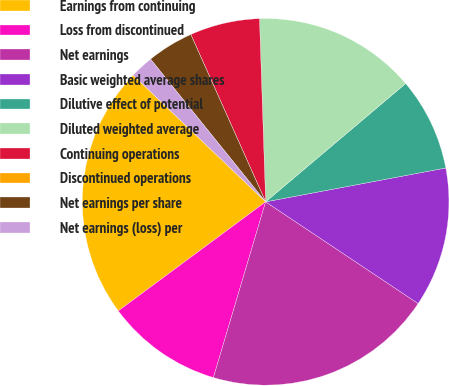Convert chart. <chart><loc_0><loc_0><loc_500><loc_500><pie_chart><fcel>Earnings from continuing<fcel>Loss from discontinued<fcel>Net earnings<fcel>Basic weighted average shares<fcel>Dilutive effect of potential<fcel>Diluted weighted average<fcel>Continuing operations<fcel>Discontinued operations<fcel>Net earnings per share<fcel>Net earnings (loss) per<nl><fcel>22.29%<fcel>10.26%<fcel>20.24%<fcel>12.32%<fcel>8.21%<fcel>14.37%<fcel>6.16%<fcel>0.0%<fcel>4.11%<fcel>2.05%<nl></chart> 